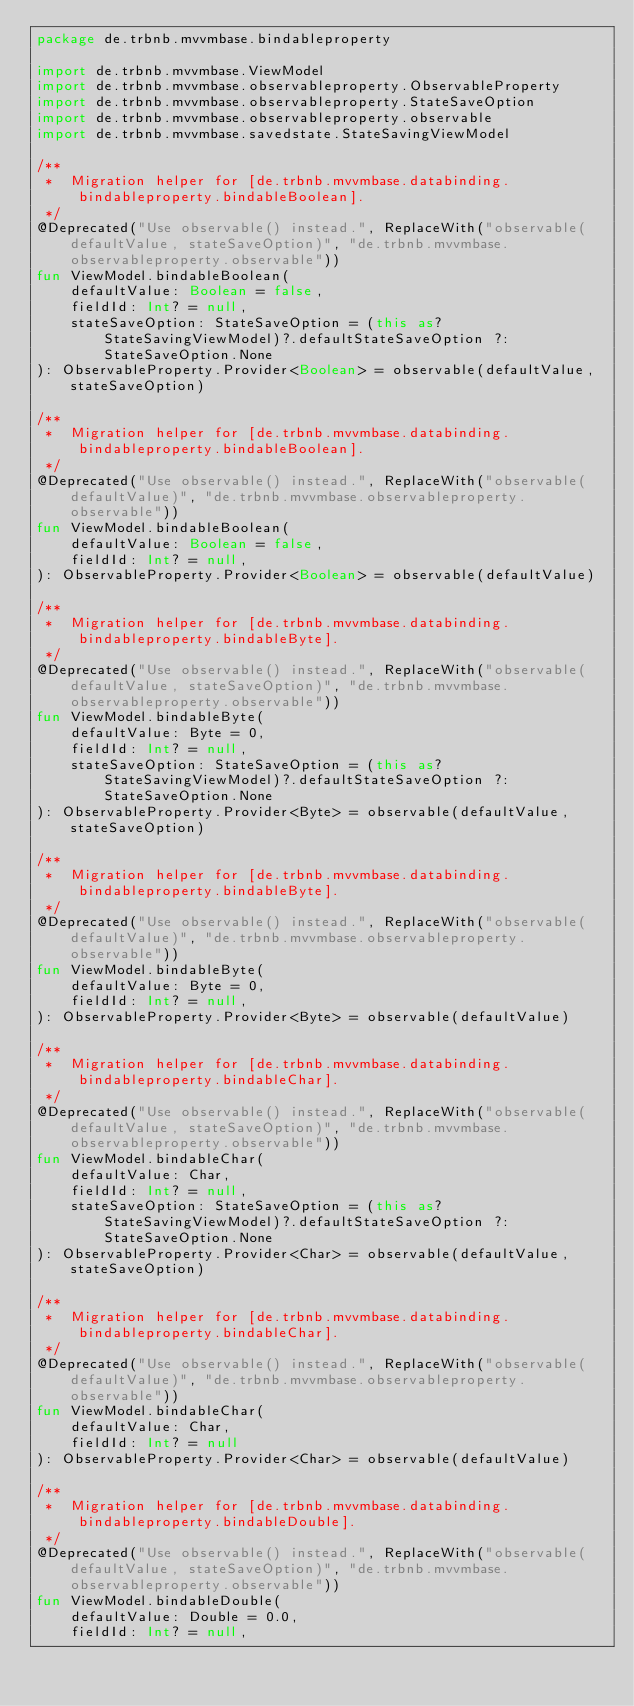<code> <loc_0><loc_0><loc_500><loc_500><_Kotlin_>package de.trbnb.mvvmbase.bindableproperty

import de.trbnb.mvvmbase.ViewModel
import de.trbnb.mvvmbase.observableproperty.ObservableProperty
import de.trbnb.mvvmbase.observableproperty.StateSaveOption
import de.trbnb.mvvmbase.observableproperty.observable
import de.trbnb.mvvmbase.savedstate.StateSavingViewModel

/**
 *  Migration helper for [de.trbnb.mvvmbase.databinding.bindableproperty.bindableBoolean].
 */
@Deprecated("Use observable() instead.", ReplaceWith("observable(defaultValue, stateSaveOption)", "de.trbnb.mvvmbase.observableproperty.observable"))
fun ViewModel.bindableBoolean(
    defaultValue: Boolean = false,
    fieldId: Int? = null,
    stateSaveOption: StateSaveOption = (this as? StateSavingViewModel)?.defaultStateSaveOption ?: StateSaveOption.None
): ObservableProperty.Provider<Boolean> = observable(defaultValue, stateSaveOption)

/**
 *  Migration helper for [de.trbnb.mvvmbase.databinding.bindableproperty.bindableBoolean].
 */
@Deprecated("Use observable() instead.", ReplaceWith("observable(defaultValue)", "de.trbnb.mvvmbase.observableproperty.observable"))
fun ViewModel.bindableBoolean(
    defaultValue: Boolean = false,
    fieldId: Int? = null,
): ObservableProperty.Provider<Boolean> = observable(defaultValue)

/**
 *  Migration helper for [de.trbnb.mvvmbase.databinding.bindableproperty.bindableByte].
 */
@Deprecated("Use observable() instead.", ReplaceWith("observable(defaultValue, stateSaveOption)", "de.trbnb.mvvmbase.observableproperty.observable"))
fun ViewModel.bindableByte(
    defaultValue: Byte = 0,
    fieldId: Int? = null,
    stateSaveOption: StateSaveOption = (this as? StateSavingViewModel)?.defaultStateSaveOption ?: StateSaveOption.None
): ObservableProperty.Provider<Byte> = observable(defaultValue, stateSaveOption)

/**
 *  Migration helper for [de.trbnb.mvvmbase.databinding.bindableproperty.bindableByte].
 */
@Deprecated("Use observable() instead.", ReplaceWith("observable(defaultValue)", "de.trbnb.mvvmbase.observableproperty.observable"))
fun ViewModel.bindableByte(
    defaultValue: Byte = 0,
    fieldId: Int? = null,
): ObservableProperty.Provider<Byte> = observable(defaultValue)

/**
 *  Migration helper for [de.trbnb.mvvmbase.databinding.bindableproperty.bindableChar].
 */
@Deprecated("Use observable() instead.", ReplaceWith("observable(defaultValue, stateSaveOption)", "de.trbnb.mvvmbase.observableproperty.observable"))
fun ViewModel.bindableChar(
    defaultValue: Char,
    fieldId: Int? = null,
    stateSaveOption: StateSaveOption = (this as? StateSavingViewModel)?.defaultStateSaveOption ?: StateSaveOption.None
): ObservableProperty.Provider<Char> = observable(defaultValue, stateSaveOption)

/**
 *  Migration helper for [de.trbnb.mvvmbase.databinding.bindableproperty.bindableChar].
 */
@Deprecated("Use observable() instead.", ReplaceWith("observable(defaultValue)", "de.trbnb.mvvmbase.observableproperty.observable"))
fun ViewModel.bindableChar(
    defaultValue: Char,
    fieldId: Int? = null
): ObservableProperty.Provider<Char> = observable(defaultValue)

/**
 *  Migration helper for [de.trbnb.mvvmbase.databinding.bindableproperty.bindableDouble].
 */
@Deprecated("Use observable() instead.", ReplaceWith("observable(defaultValue, stateSaveOption)", "de.trbnb.mvvmbase.observableproperty.observable"))
fun ViewModel.bindableDouble(
    defaultValue: Double = 0.0,
    fieldId: Int? = null,</code> 